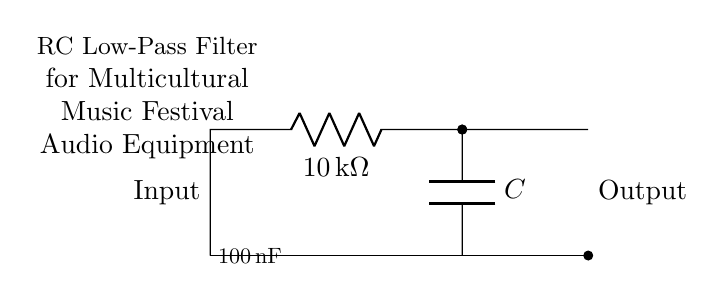What is the resistance in this circuit? The resistance is indicated on the resistor, labeled as 10 kilohms.
Answer: 10 kilohms What is the capacitance value used in the circuit? The circuit diagram shows the capacitor value, which is specified as 100 nanofarads.
Answer: 100 nanofarads What type of filter does this circuit represent? The circuit diagram describes an RC low-pass filter, as labeled in the diagram.
Answer: RC low-pass filter What is the function of a low-pass filter in audio equipment? A low-pass filter allows signals below a certain frequency to pass through while attenuating higher frequencies, making it suitable for audio signals.
Answer: Allow low frequencies How do you determine the cutoff frequency of this RC filter? The cutoff frequency can be calculated using the formula: cutoff frequency equals one over two pi times the product of resistance and capacitance.
Answer: One over two pi RC What can you infer about the input and output connections? The input is connected at the top of the circuit, while the output is taken from the bottom, indicating the direction of signal flow through the filter.
Answer: Input at the top, output at the bottom How does increasing the resistance value affect the filter's cutoff frequency? Increasing the resistance value will decrease the cutoff frequency since it is inversely proportional to resistance in the cutoff frequency calculation.
Answer: Decreases cutoff frequency 